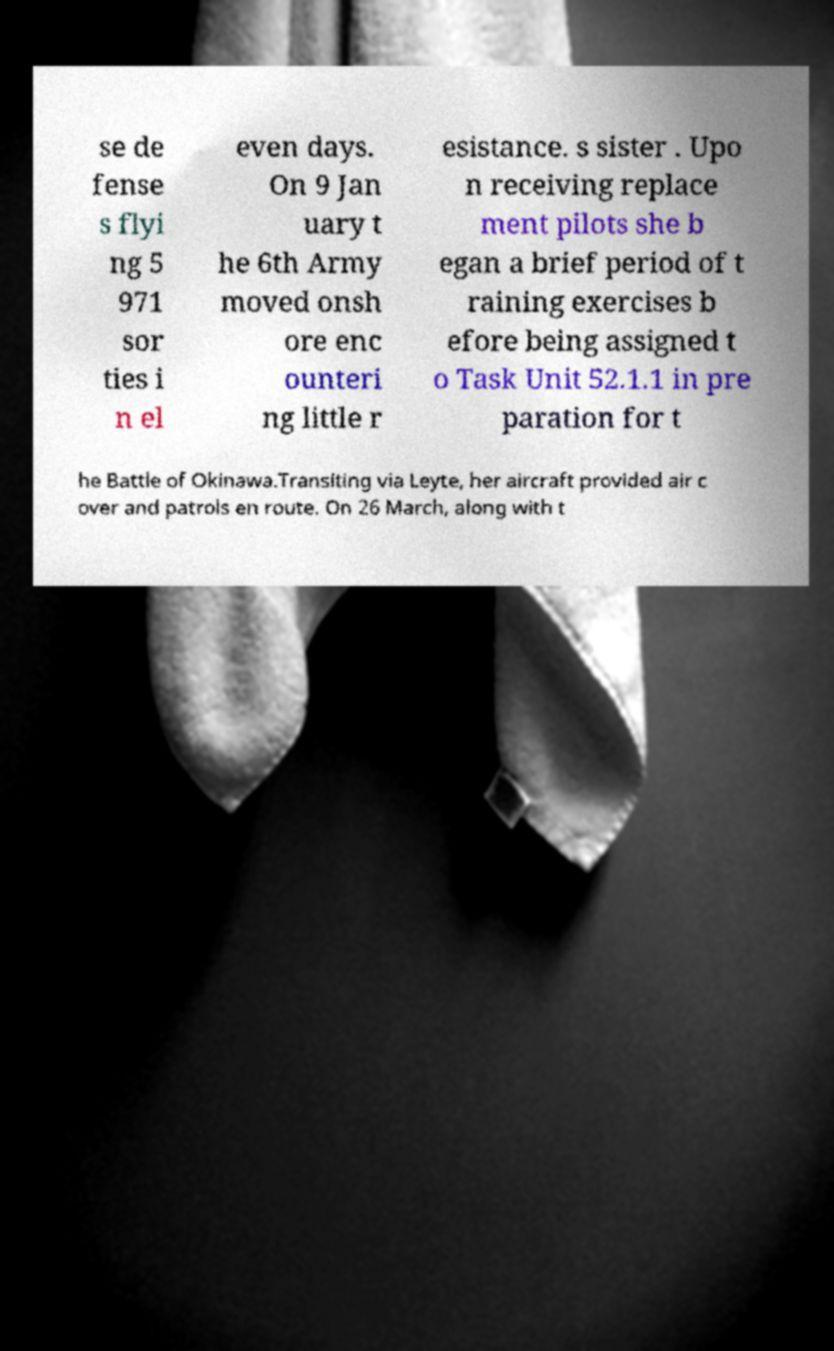Could you assist in decoding the text presented in this image and type it out clearly? se de fense s flyi ng 5 971 sor ties i n el even days. On 9 Jan uary t he 6th Army moved onsh ore enc ounteri ng little r esistance. s sister . Upo n receiving replace ment pilots she b egan a brief period of t raining exercises b efore being assigned t o Task Unit 52.1.1 in pre paration for t he Battle of Okinawa.Transiting via Leyte, her aircraft provided air c over and patrols en route. On 26 March, along with t 